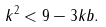<formula> <loc_0><loc_0><loc_500><loc_500>k ^ { 2 } < 9 - 3 k b .</formula> 